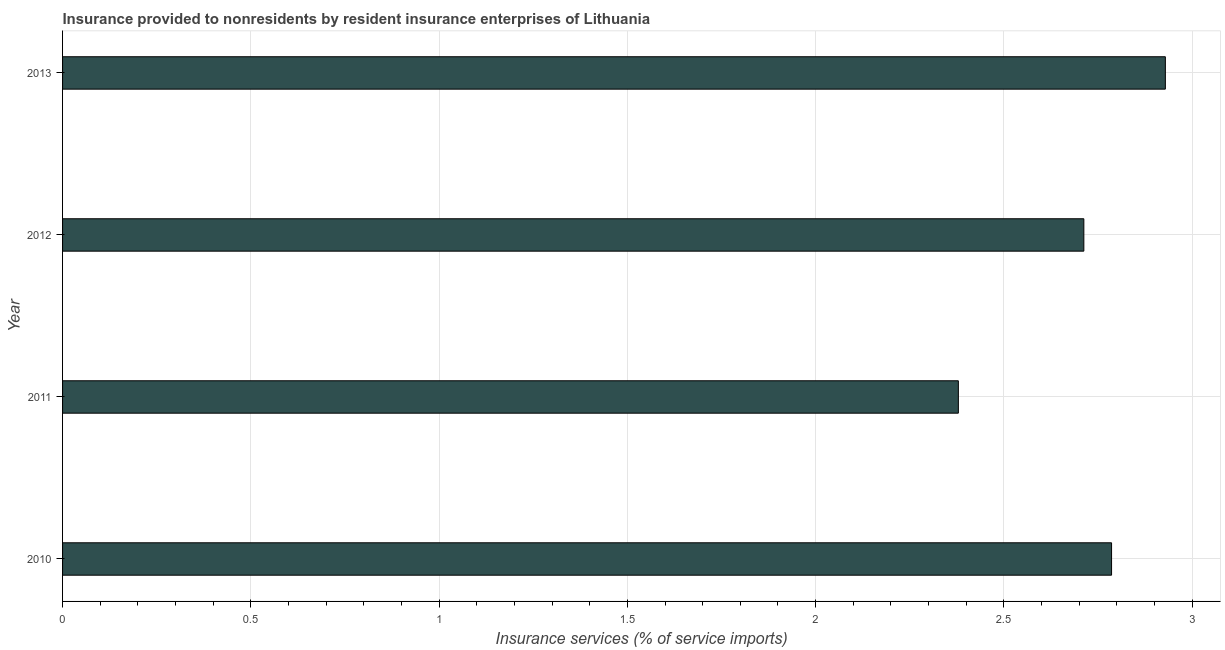Does the graph contain any zero values?
Your answer should be very brief. No. What is the title of the graph?
Ensure brevity in your answer.  Insurance provided to nonresidents by resident insurance enterprises of Lithuania. What is the label or title of the X-axis?
Your response must be concise. Insurance services (% of service imports). What is the label or title of the Y-axis?
Give a very brief answer. Year. What is the insurance and financial services in 2010?
Ensure brevity in your answer.  2.79. Across all years, what is the maximum insurance and financial services?
Your answer should be compact. 2.93. Across all years, what is the minimum insurance and financial services?
Give a very brief answer. 2.38. In which year was the insurance and financial services maximum?
Your response must be concise. 2013. What is the sum of the insurance and financial services?
Your answer should be very brief. 10.81. What is the difference between the insurance and financial services in 2010 and 2012?
Provide a short and direct response. 0.07. What is the average insurance and financial services per year?
Ensure brevity in your answer.  2.7. What is the median insurance and financial services?
Give a very brief answer. 2.75. In how many years, is the insurance and financial services greater than 1.3 %?
Provide a succinct answer. 4. Do a majority of the years between 2010 and 2012 (inclusive) have insurance and financial services greater than 2.1 %?
Ensure brevity in your answer.  Yes. What is the difference between the highest and the second highest insurance and financial services?
Your answer should be very brief. 0.14. Is the sum of the insurance and financial services in 2012 and 2013 greater than the maximum insurance and financial services across all years?
Your answer should be compact. Yes. What is the difference between the highest and the lowest insurance and financial services?
Offer a very short reply. 0.55. In how many years, is the insurance and financial services greater than the average insurance and financial services taken over all years?
Your answer should be compact. 3. How many bars are there?
Make the answer very short. 4. Are all the bars in the graph horizontal?
Provide a short and direct response. Yes. How many years are there in the graph?
Offer a very short reply. 4. What is the difference between two consecutive major ticks on the X-axis?
Your response must be concise. 0.5. Are the values on the major ticks of X-axis written in scientific E-notation?
Provide a short and direct response. No. What is the Insurance services (% of service imports) of 2010?
Your response must be concise. 2.79. What is the Insurance services (% of service imports) in 2011?
Your answer should be compact. 2.38. What is the Insurance services (% of service imports) of 2012?
Offer a very short reply. 2.71. What is the Insurance services (% of service imports) of 2013?
Provide a succinct answer. 2.93. What is the difference between the Insurance services (% of service imports) in 2010 and 2011?
Offer a terse response. 0.41. What is the difference between the Insurance services (% of service imports) in 2010 and 2012?
Keep it short and to the point. 0.07. What is the difference between the Insurance services (% of service imports) in 2010 and 2013?
Ensure brevity in your answer.  -0.14. What is the difference between the Insurance services (% of service imports) in 2011 and 2012?
Give a very brief answer. -0.33. What is the difference between the Insurance services (% of service imports) in 2011 and 2013?
Make the answer very short. -0.55. What is the difference between the Insurance services (% of service imports) in 2012 and 2013?
Ensure brevity in your answer.  -0.22. What is the ratio of the Insurance services (% of service imports) in 2010 to that in 2011?
Offer a terse response. 1.17. What is the ratio of the Insurance services (% of service imports) in 2010 to that in 2013?
Provide a short and direct response. 0.95. What is the ratio of the Insurance services (% of service imports) in 2011 to that in 2012?
Give a very brief answer. 0.88. What is the ratio of the Insurance services (% of service imports) in 2011 to that in 2013?
Your answer should be compact. 0.81. What is the ratio of the Insurance services (% of service imports) in 2012 to that in 2013?
Your answer should be very brief. 0.93. 